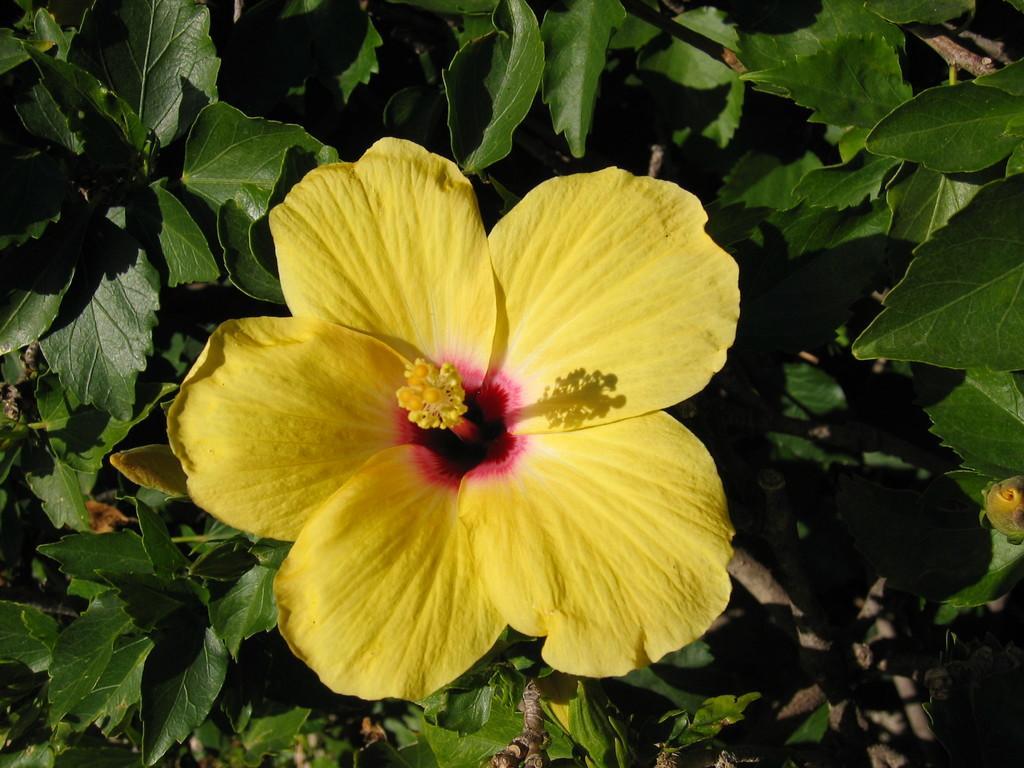Could you give a brief overview of what you see in this image? In this image there is a flower, around the flower there are leaves and branches. 